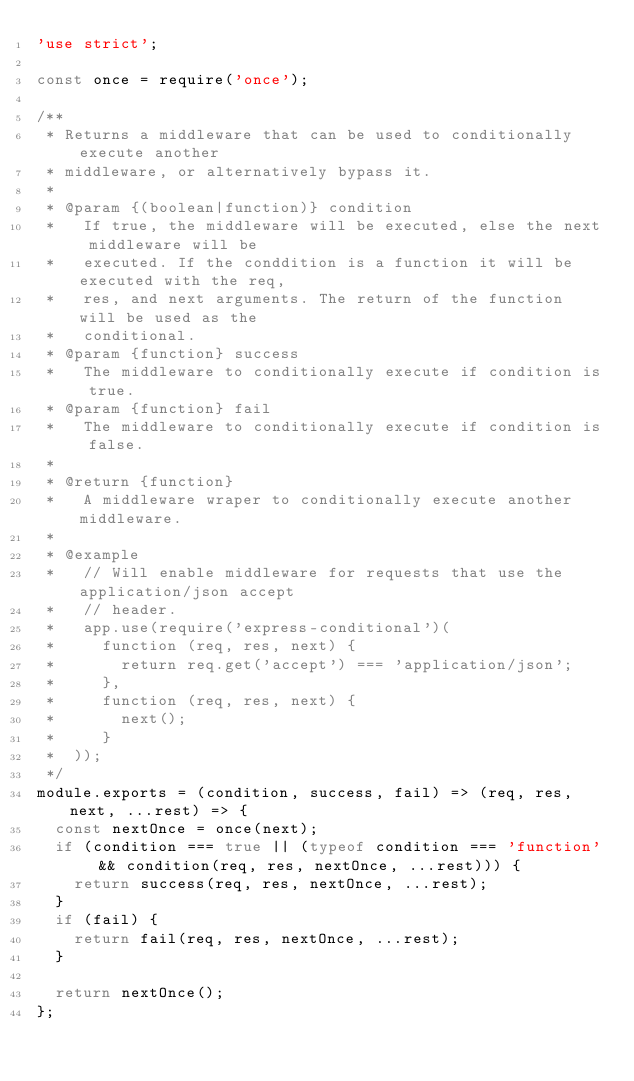<code> <loc_0><loc_0><loc_500><loc_500><_JavaScript_>'use strict';

const once = require('once');

/**
 * Returns a middleware that can be used to conditionally execute another
 * middleware, or alternatively bypass it.
 *
 * @param {(boolean|function)} condition
 *   If true, the middleware will be executed, else the next middleware will be
 *   executed. If the conddition is a function it will be executed with the req,
 *   res, and next arguments. The return of the function will be used as the
 *   conditional.
 * @param {function} success
 *   The middleware to conditionally execute if condition is true.
 * @param {function} fail
 *   The middleware to conditionally execute if condition is false.
 *
 * @return {function}
 *   A middleware wraper to conditionally execute another middleware.
 *
 * @example
 *   // Will enable middleware for requests that use the application/json accept
 *   // header.
 *   app.use(require('express-conditional')(
 *     function (req, res, next) {
 *       return req.get('accept') === 'application/json';
 *     },
 *     function (req, res, next) {
 *       next();
 *     }
 *  ));
 */
module.exports = (condition, success, fail) => (req, res, next, ...rest) => {
  const nextOnce = once(next);
  if (condition === true || (typeof condition === 'function' && condition(req, res, nextOnce, ...rest))) {
    return success(req, res, nextOnce, ...rest);
  }
  if (fail) {
    return fail(req, res, nextOnce, ...rest);
  }

  return nextOnce();
};
</code> 